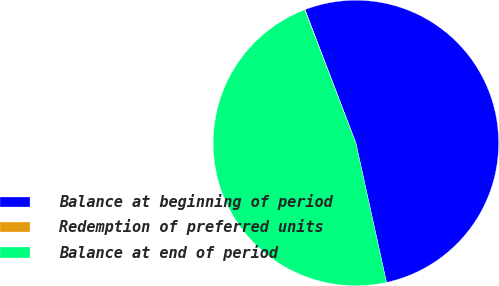<chart> <loc_0><loc_0><loc_500><loc_500><pie_chart><fcel>Balance at beginning of period<fcel>Redemption of preferred units<fcel>Balance at end of period<nl><fcel>52.36%<fcel>0.04%<fcel>47.6%<nl></chart> 